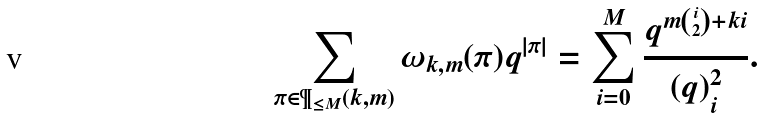<formula> <loc_0><loc_0><loc_500><loc_500>\sum _ { \pi \in \P _ { \leq M } ( k , m ) } \omega _ { k , m } ( \pi ) q ^ { | \pi | } = \sum _ { i = 0 } ^ { M } \frac { q ^ { m { i \choose 2 } + k i } } { ( q ) _ { i } ^ { 2 } } .</formula> 